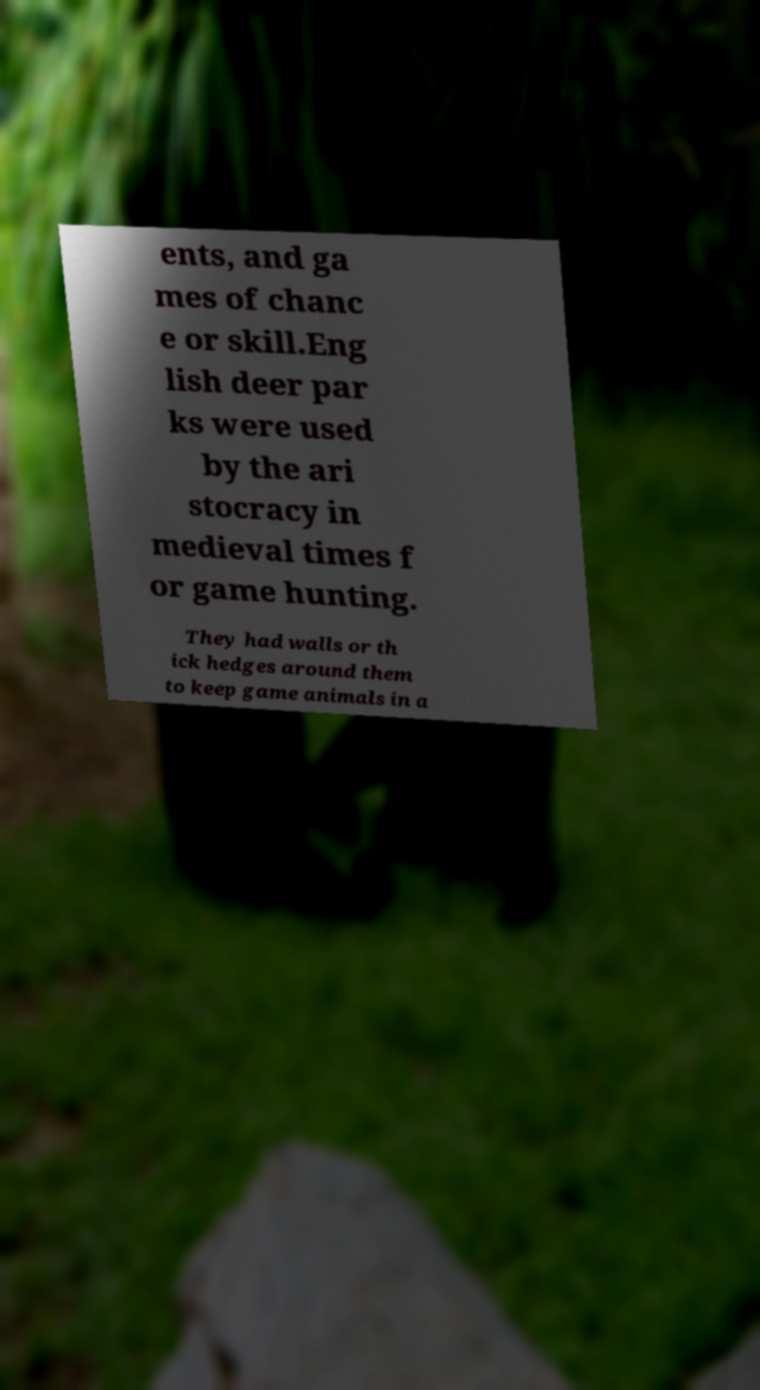Please identify and transcribe the text found in this image. ents, and ga mes of chanc e or skill.Eng lish deer par ks were used by the ari stocracy in medieval times f or game hunting. They had walls or th ick hedges around them to keep game animals in a 